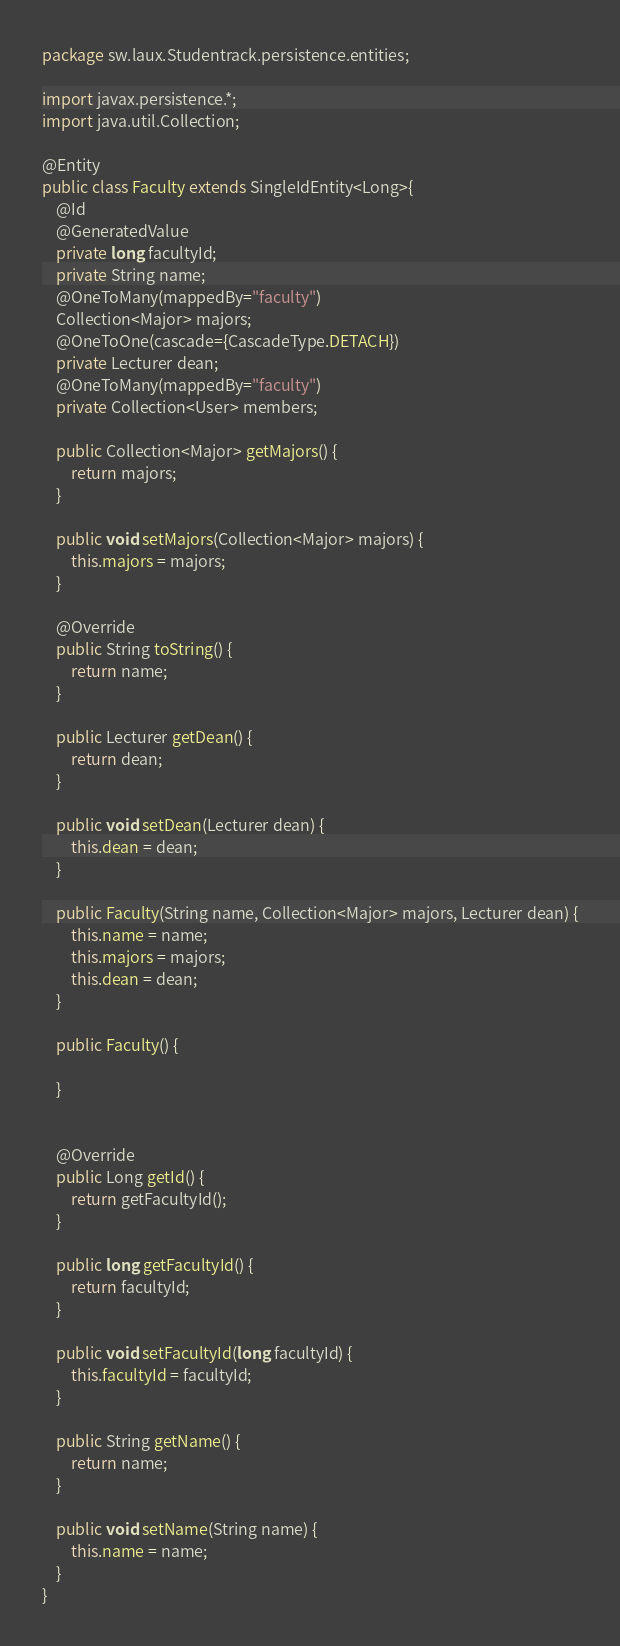<code> <loc_0><loc_0><loc_500><loc_500><_Java_>package sw.laux.Studentrack.persistence.entities;

import javax.persistence.*;
import java.util.Collection;

@Entity
public class Faculty extends SingleIdEntity<Long>{
    @Id
    @GeneratedValue
    private long facultyId;
    private String name;
    @OneToMany(mappedBy="faculty")
    Collection<Major> majors;
    @OneToOne(cascade={CascadeType.DETACH})
    private Lecturer dean;
    @OneToMany(mappedBy="faculty")
    private Collection<User> members;

    public Collection<Major> getMajors() {
        return majors;
    }

    public void setMajors(Collection<Major> majors) {
        this.majors = majors;
    }

    @Override
    public String toString() {
        return name;
    }

    public Lecturer getDean() {
        return dean;
    }

    public void setDean(Lecturer dean) {
        this.dean = dean;
    }

    public Faculty(String name, Collection<Major> majors, Lecturer dean) {
        this.name = name;
        this.majors = majors;
        this.dean = dean;
    }

    public Faculty() {

    }


    @Override
    public Long getId() {
        return getFacultyId();
    }

    public long getFacultyId() {
        return facultyId;
    }

    public void setFacultyId(long facultyId) {
        this.facultyId = facultyId;
    }

    public String getName() {
        return name;
    }

    public void setName(String name) {
        this.name = name;
    }
}
</code> 